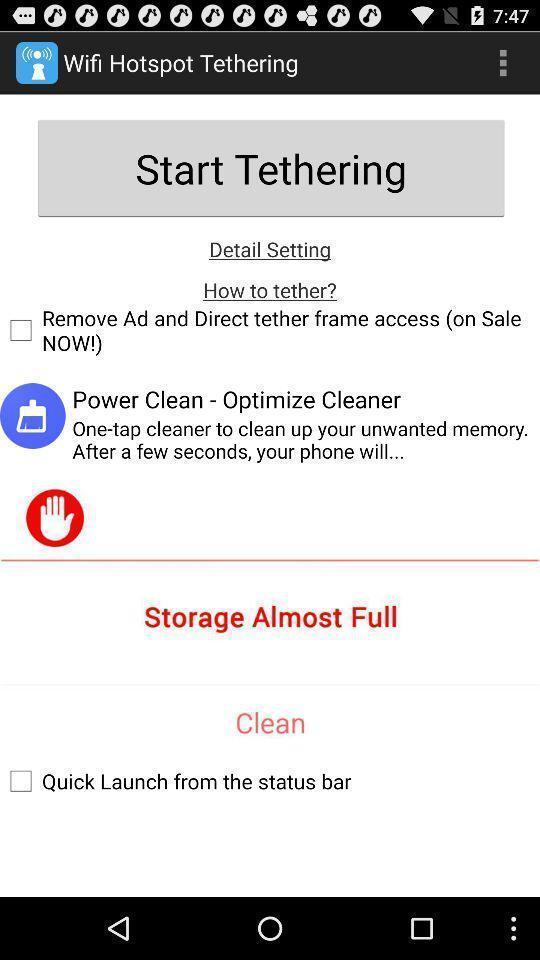Describe the key features of this screenshot. Start tethering in wifi hotspot tethering. 